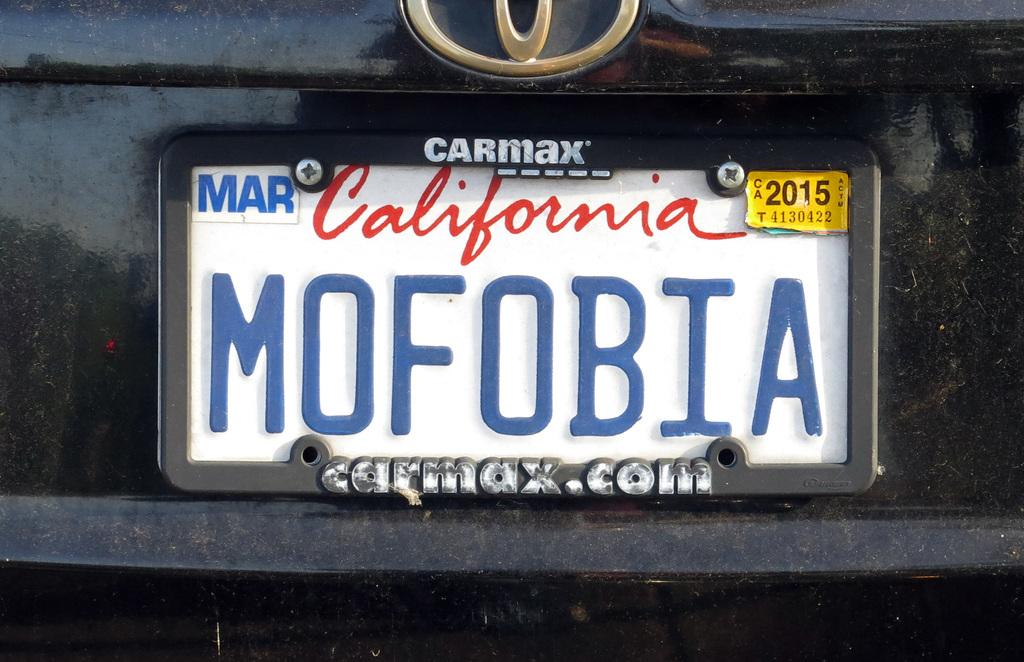What state is this license plate from?
Provide a short and direct response. California. What is the year of registration?
Offer a very short reply. 2015. 